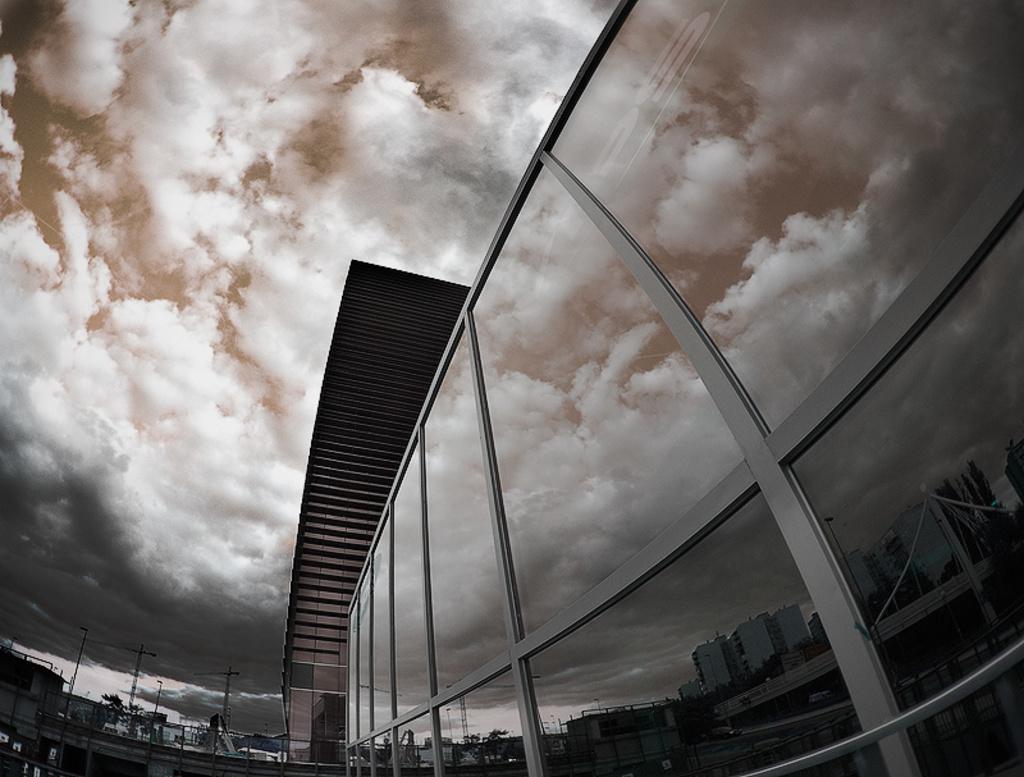How would you summarize this image in a sentence or two? In this image we can see buildings and poles. In the background there is sky with clouds. On the glasses we can see the reflection. 